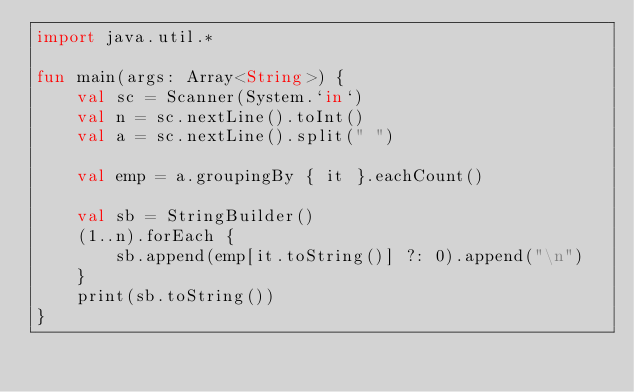<code> <loc_0><loc_0><loc_500><loc_500><_Kotlin_>import java.util.*

fun main(args: Array<String>) {
    val sc = Scanner(System.`in`)
    val n = sc.nextLine().toInt()
    val a = sc.nextLine().split(" ")

    val emp = a.groupingBy { it }.eachCount()

    val sb = StringBuilder()
    (1..n).forEach {
        sb.append(emp[it.toString()] ?: 0).append("\n")
    }
    print(sb.toString())
}</code> 